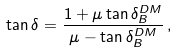Convert formula to latex. <formula><loc_0><loc_0><loc_500><loc_500>\tan \delta = \frac { 1 + \mu \tan \delta _ { B } ^ { D M } } { \mu - \tan \delta _ { B } ^ { D M } } \, ,</formula> 